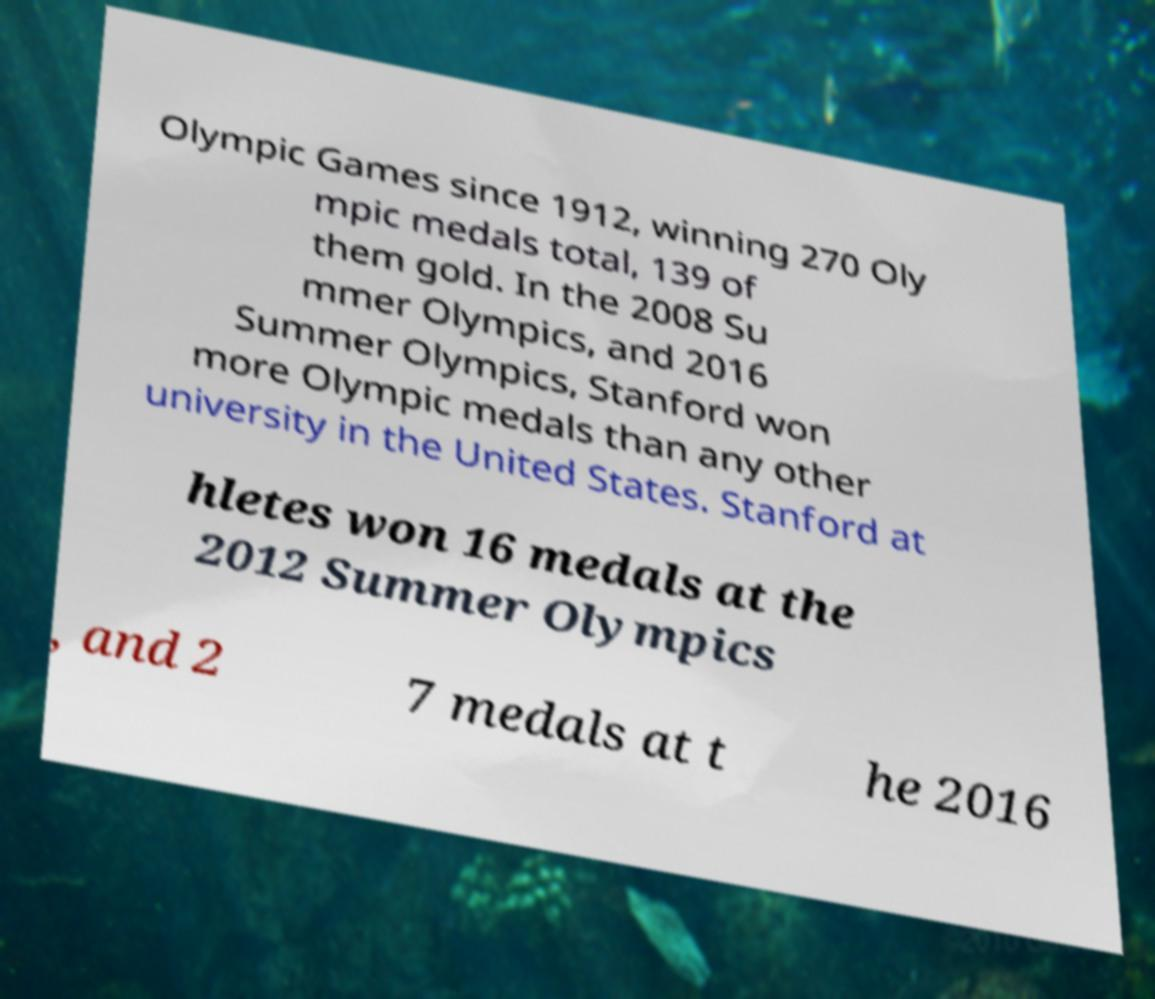Can you read and provide the text displayed in the image?This photo seems to have some interesting text. Can you extract and type it out for me? Olympic Games since 1912, winning 270 Oly mpic medals total, 139 of them gold. In the 2008 Su mmer Olympics, and 2016 Summer Olympics, Stanford won more Olympic medals than any other university in the United States. Stanford at hletes won 16 medals at the 2012 Summer Olympics , and 2 7 medals at t he 2016 